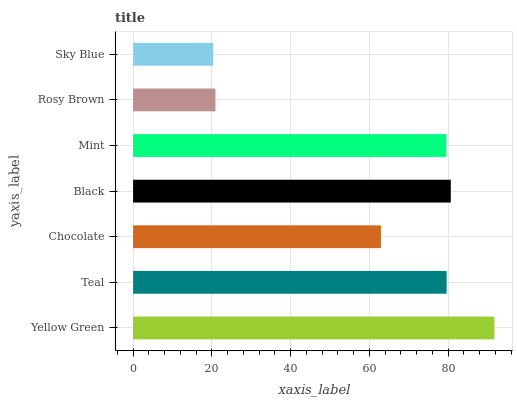Is Sky Blue the minimum?
Answer yes or no. Yes. Is Yellow Green the maximum?
Answer yes or no. Yes. Is Teal the minimum?
Answer yes or no. No. Is Teal the maximum?
Answer yes or no. No. Is Yellow Green greater than Teal?
Answer yes or no. Yes. Is Teal less than Yellow Green?
Answer yes or no. Yes. Is Teal greater than Yellow Green?
Answer yes or no. No. Is Yellow Green less than Teal?
Answer yes or no. No. Is Mint the high median?
Answer yes or no. Yes. Is Mint the low median?
Answer yes or no. Yes. Is Chocolate the high median?
Answer yes or no. No. Is Yellow Green the low median?
Answer yes or no. No. 